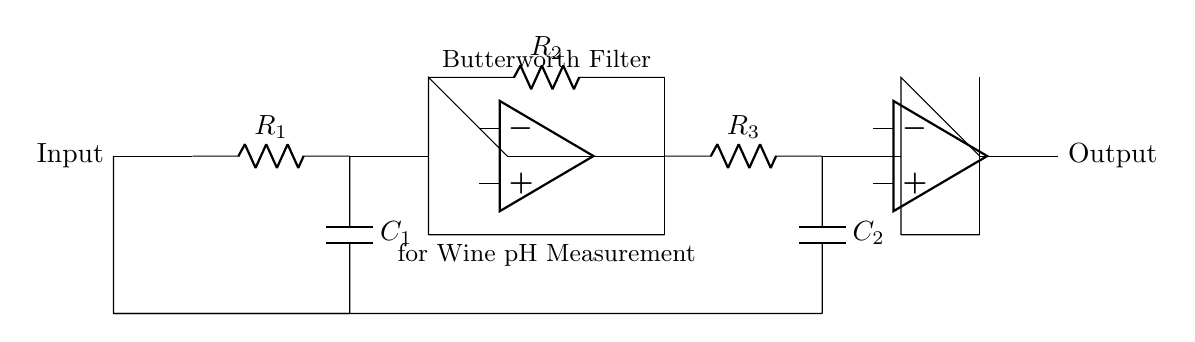What type of filter is represented in this circuit? The circuit diagram shows a Butterworth filter, which is characterized by its smooth frequency response and no ripples in the passband. This is confirmed by the labeled "Butterworth Filter" component in the diagram.
Answer: Butterworth filter How many resistors are in the circuit? The circuit diagram includes three resistors: R1, R2, and R3, which can be counted directly in the diagram.
Answer: Three What is the function of the operational amplifiers in this circuit? The operational amplifiers in the circuit serve to amplify the filtered signal and buffer it, which isolates the filter from the load. This dual op-amp representation is indicated by the symbol used in the diagram.
Answer: Amplify and buffer What is the total capacitance in the circuit? There are two capacitors, C1 and C2. The total capacitance of a Butterworth filter can vary based on their configuration, but the diagram shows them in series with their values not specified; so it's specifically "C1 and C2".
Answer: C1 and C2 Why is the Butterworth filter suitable for wine pH measurement? The Butterworth filter provides a flat frequency response, minimizing phase distortion, which makes it ideal for precise signal processing in applications like pH measurement where accurate readings are critical.
Answer: Flat frequency response 